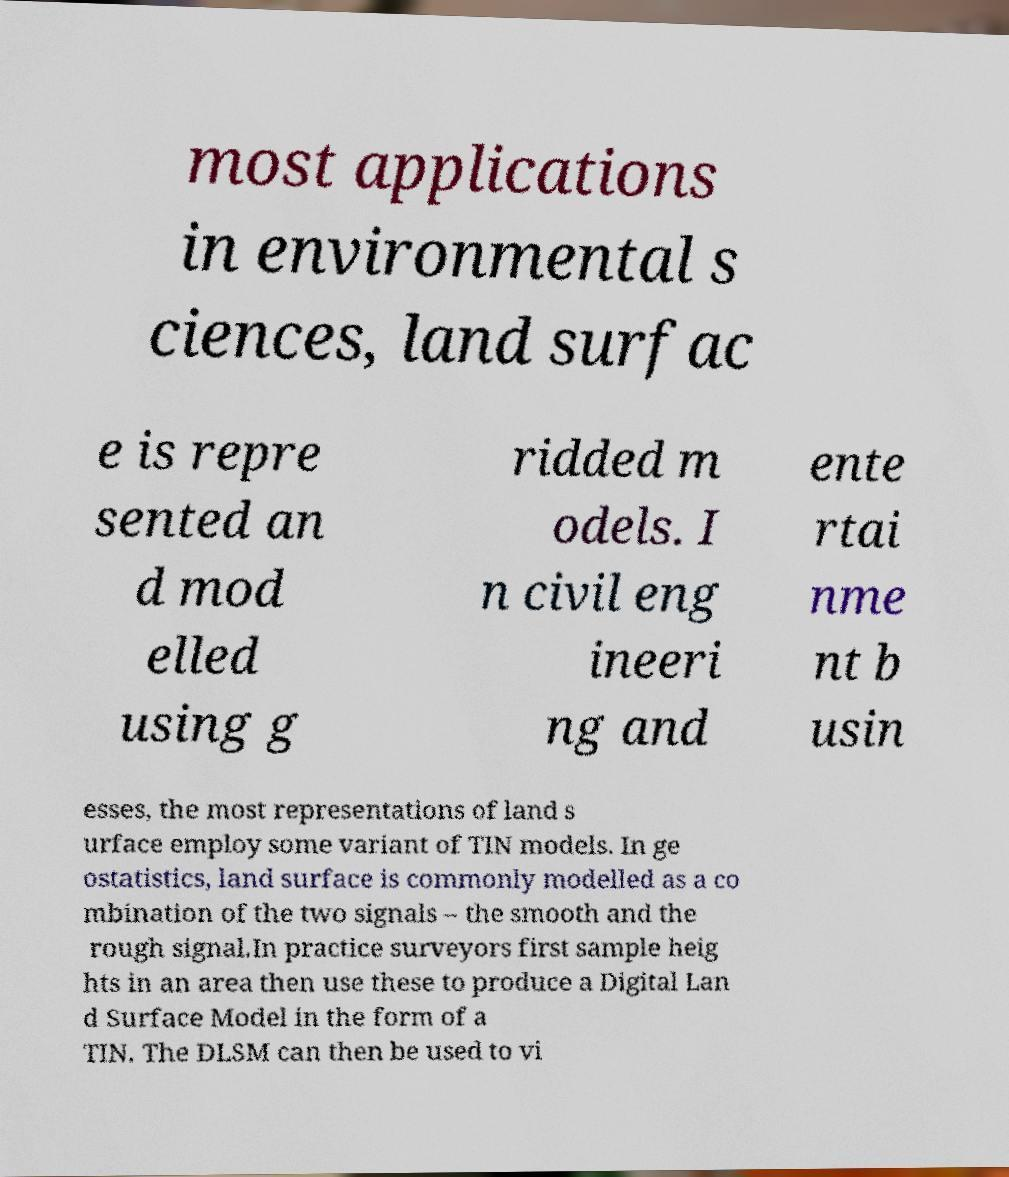What messages or text are displayed in this image? I need them in a readable, typed format. most applications in environmental s ciences, land surfac e is repre sented an d mod elled using g ridded m odels. I n civil eng ineeri ng and ente rtai nme nt b usin esses, the most representations of land s urface employ some variant of TIN models. In ge ostatistics, land surface is commonly modelled as a co mbination of the two signals – the smooth and the rough signal.In practice surveyors first sample heig hts in an area then use these to produce a Digital Lan d Surface Model in the form of a TIN. The DLSM can then be used to vi 